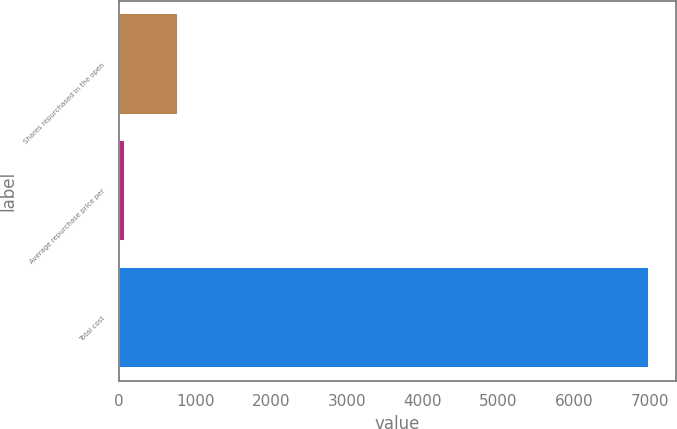<chart> <loc_0><loc_0><loc_500><loc_500><bar_chart><fcel>Shares repurchased in the open<fcel>Average repurchase price per<fcel>Total cost<nl><fcel>768.04<fcel>77.05<fcel>6987<nl></chart> 